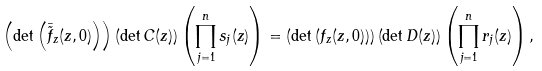Convert formula to latex. <formula><loc_0><loc_0><loc_500><loc_500>\left ( \det \left ( \bar { \tilde { f } } _ { z } ( z , 0 ) \right ) \right ) \left ( \det C ( z ) \right ) \left ( \prod _ { j = 1 } ^ { n } s _ { j } ( z ) \right ) = \left ( \det \left ( f _ { z } ( z , 0 ) \right ) \right ) \left ( \det D ( z ) \right ) \left ( \prod _ { j = 1 } ^ { n } r _ { j } ( z ) \right ) ,</formula> 